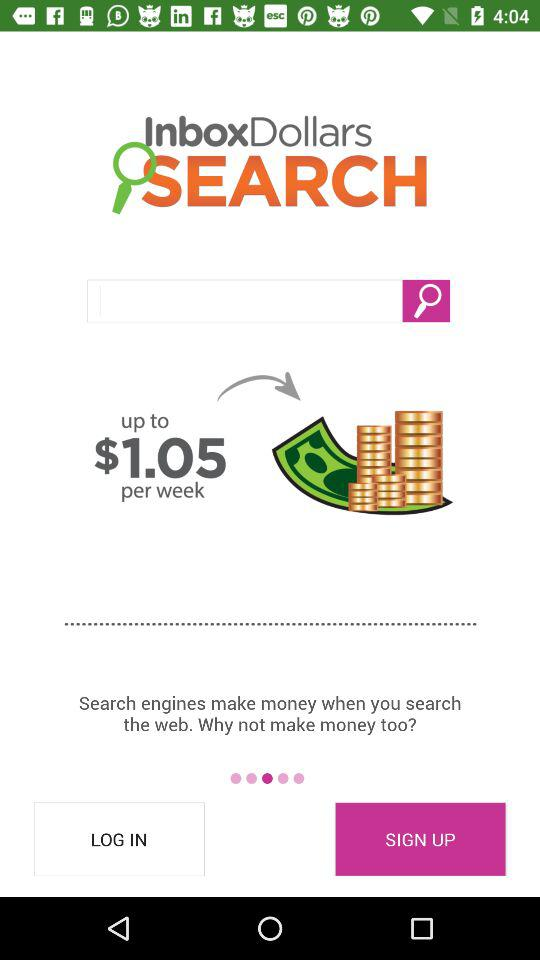What is the application name? The application name is "InboxDollars". 